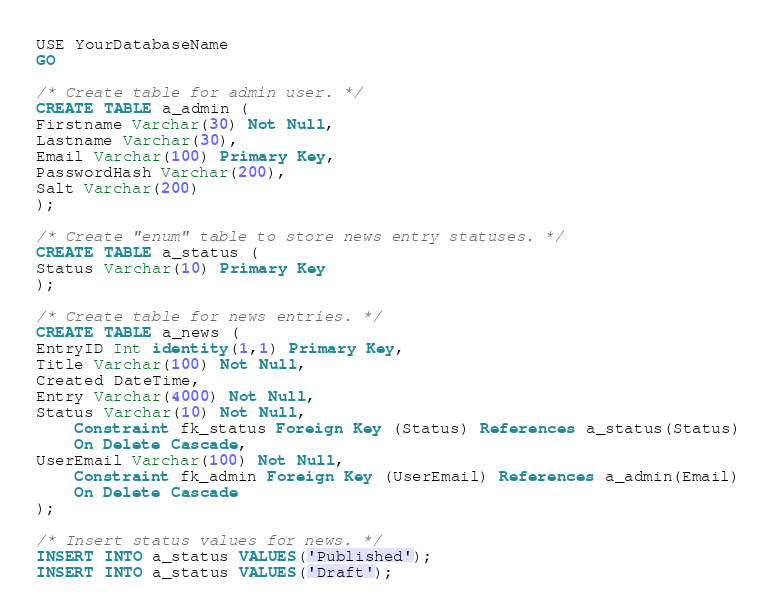<code> <loc_0><loc_0><loc_500><loc_500><_SQL_>USE YourDatabaseName
GO

/* Create table for admin user. */
CREATE TABLE a_admin (
Firstname Varchar(30) Not Null,
Lastname Varchar(30),
Email Varchar(100) Primary Key,
PasswordHash Varchar(200),
Salt Varchar(200)
);

/* Create "enum" table to store news entry statuses. */
CREATE TABLE a_status (
Status Varchar(10) Primary Key
);

/* Create table for news entries. */
CREATE TABLE a_news (
EntryID Int identity(1,1) Primary Key,
Title Varchar(100) Not Null,
Created DateTime,
Entry Varchar(4000) Not Null,
Status Varchar(10) Not Null,
	Constraint fk_status Foreign Key (Status) References a_status(Status)
	On Delete Cascade,
UserEmail Varchar(100) Not Null,
	Constraint fk_admin Foreign Key (UserEmail) References a_admin(Email)
    On Delete Cascade
);

/* Insert status values for news. */
INSERT INTO a_status VALUES('Published');
INSERT INTO a_status VALUES('Draft');</code> 